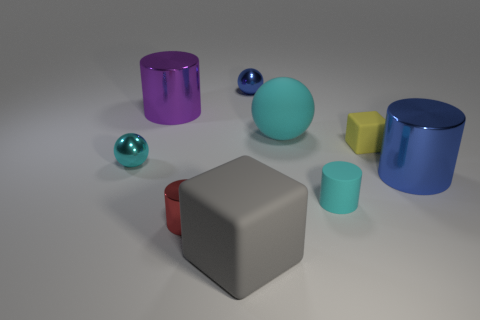What number of blue things are small things or rubber spheres?
Your answer should be very brief. 1. What number of matte objects have the same color as the matte sphere?
Your response must be concise. 1. What number of cylinders are brown things or purple objects?
Offer a very short reply. 1. There is a large matte thing in front of the big blue metal cylinder; what is its color?
Give a very brief answer. Gray. What is the shape of the blue shiny thing that is the same size as the gray matte cube?
Offer a very short reply. Cylinder. What number of blue balls are behind the big blue cylinder?
Your answer should be compact. 1. What number of things are blue cylinders or blue shiny balls?
Give a very brief answer. 2. What shape is the tiny metallic object that is in front of the small blue metallic object and behind the blue metal cylinder?
Make the answer very short. Sphere. What number of purple things are there?
Your answer should be very brief. 1. There is another large thing that is the same material as the big gray object; what is its color?
Give a very brief answer. Cyan. 